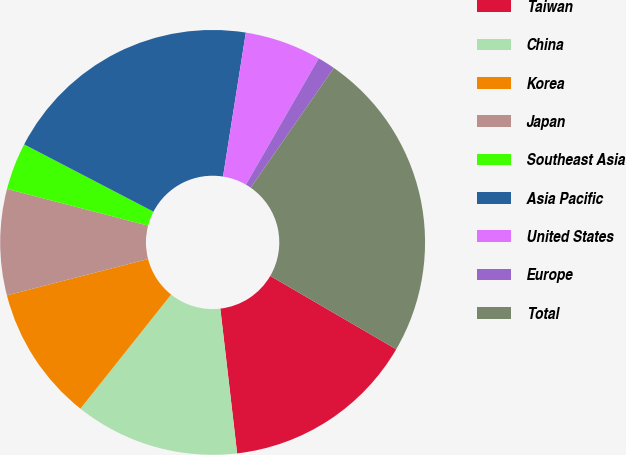<chart> <loc_0><loc_0><loc_500><loc_500><pie_chart><fcel>Taiwan<fcel>China<fcel>Korea<fcel>Japan<fcel>Southeast Asia<fcel>Asia Pacific<fcel>United States<fcel>Europe<fcel>Total<nl><fcel>14.77%<fcel>12.53%<fcel>10.3%<fcel>8.06%<fcel>3.58%<fcel>19.87%<fcel>5.82%<fcel>1.35%<fcel>23.72%<nl></chart> 